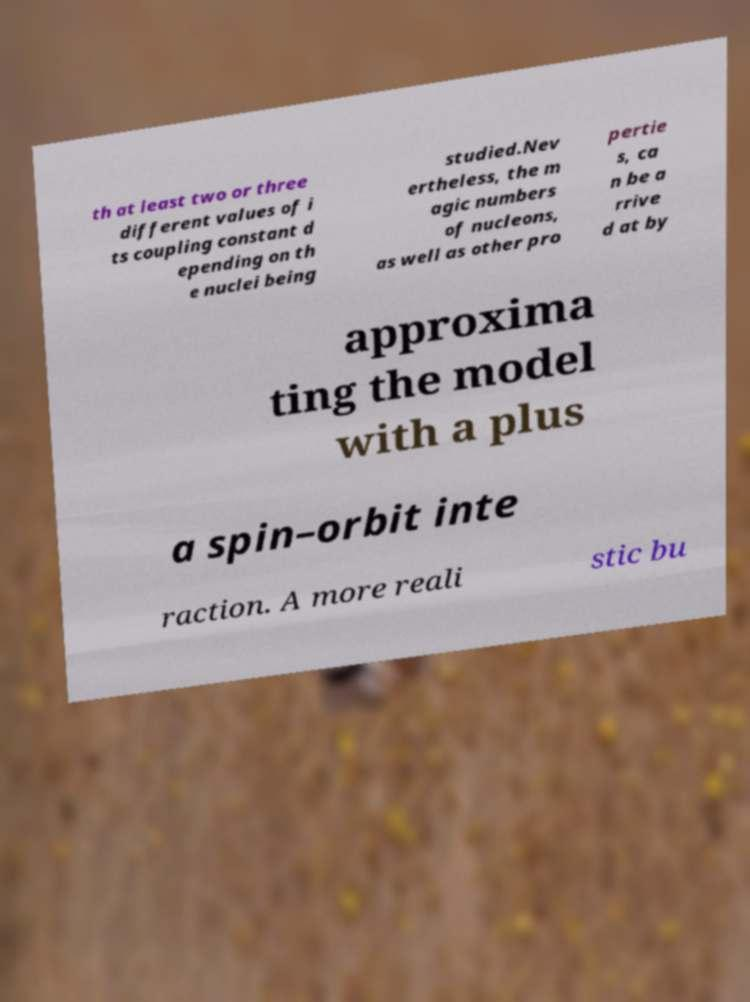I need the written content from this picture converted into text. Can you do that? th at least two or three different values of i ts coupling constant d epending on th e nuclei being studied.Nev ertheless, the m agic numbers of nucleons, as well as other pro pertie s, ca n be a rrive d at by approxima ting the model with a plus a spin–orbit inte raction. A more reali stic bu 